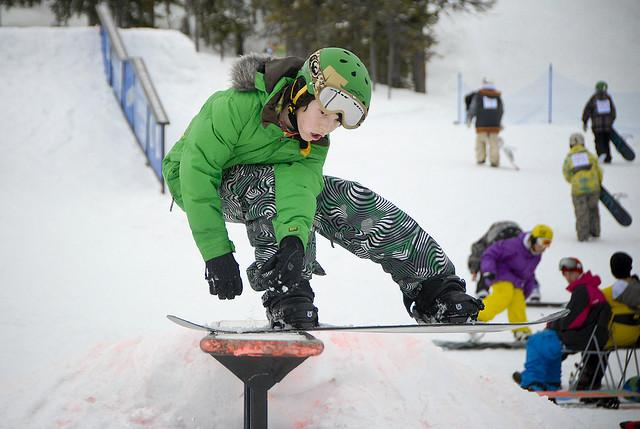Who watches these people while they board on snow? spectators 